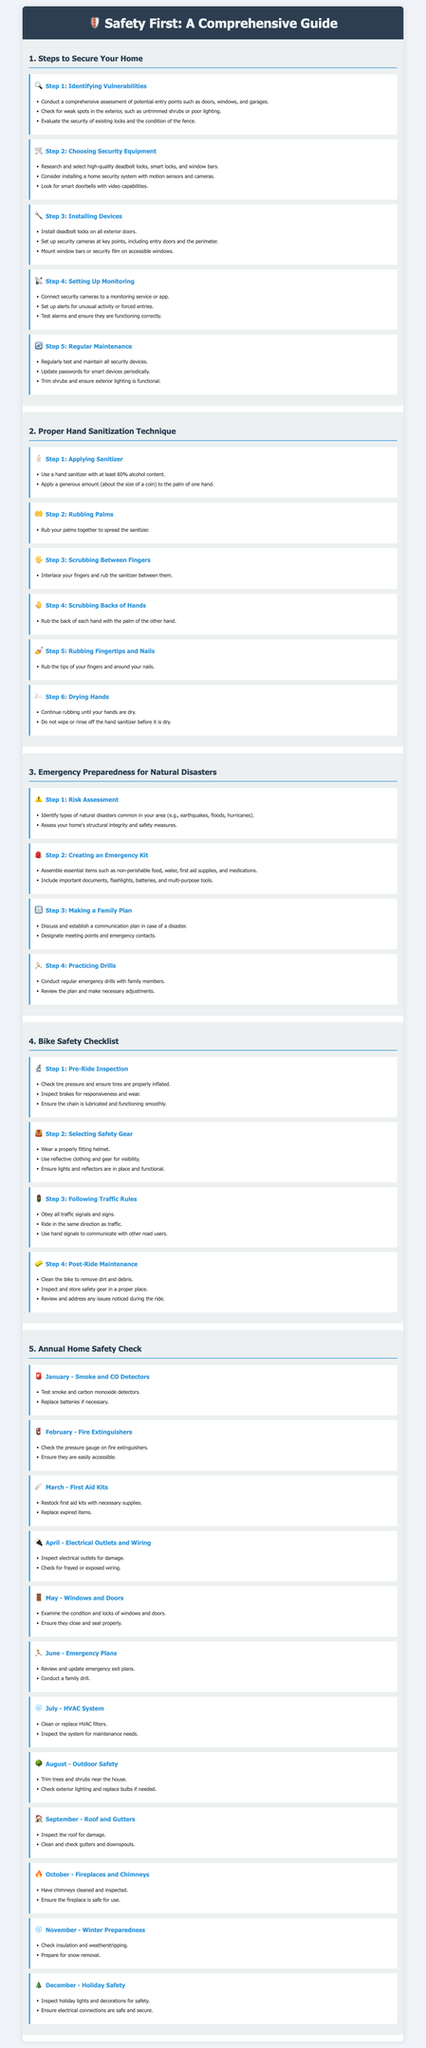what is the first step to secure your home? The first step to secure your home is identifying vulnerabilities.
Answer: identifying vulnerabilities how many steps are there in the proper hand sanitization technique? There are six steps in the proper hand sanitization technique.
Answer: six steps what should you check for in February during the annual home safety check? In February, you should check the pressure gauge on fire extinguishers.
Answer: pressure gauge on fire extinguishers which month is dedicated to inspecting windows and doors? May is the month dedicated to inspecting windows and doors.
Answer: May what is included in the emergency kit? The emergency kit includes essential items such as non-perishable food, water, first aid supplies, and medications.
Answer: non-perishable food, water, first aid supplies, and medications what is the icon for the step of installing devices in home security? The icon for the step of installing devices is a wrench.
Answer: wrench how often should you test and maintain all security devices? You should regularly test and maintain all security devices.
Answer: regularly what is the primary purpose of the bike safety checklist? The primary purpose of the bike safety checklist is to ensure a safe ride every time.
Answer: ensure a safe ride every time how many processes are listed under emergency preparedness for natural disasters? There are four processes listed under emergency preparedness for natural disasters.
Answer: four processes 